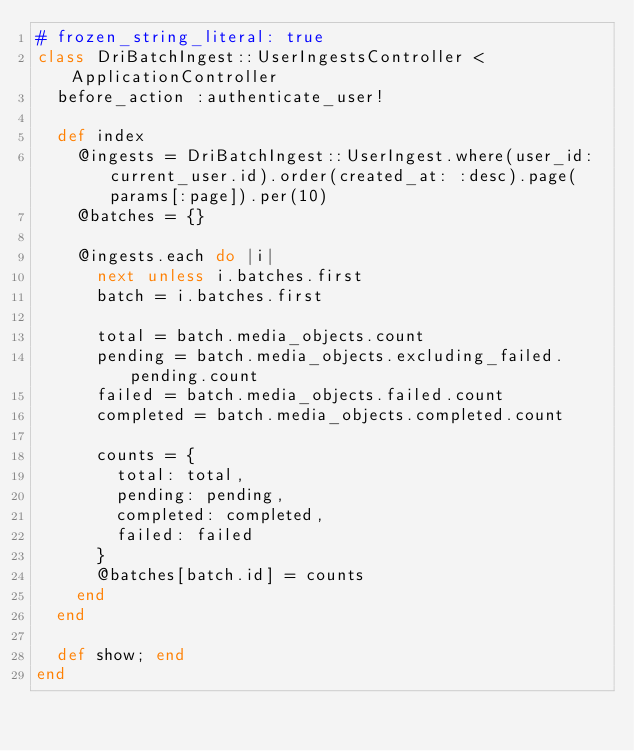<code> <loc_0><loc_0><loc_500><loc_500><_Ruby_># frozen_string_literal: true
class DriBatchIngest::UserIngestsController < ApplicationController
  before_action :authenticate_user!

  def index
    @ingests = DriBatchIngest::UserIngest.where(user_id: current_user.id).order(created_at: :desc).page(params[:page]).per(10)
    @batches = {}

    @ingests.each do |i|
      next unless i.batches.first
      batch = i.batches.first

      total = batch.media_objects.count
      pending = batch.media_objects.excluding_failed.pending.count
      failed = batch.media_objects.failed.count
      completed = batch.media_objects.completed.count

      counts = {
        total: total,
        pending: pending,
        completed: completed,
        failed: failed
      }
      @batches[batch.id] = counts
    end
  end

  def show; end
end
</code> 